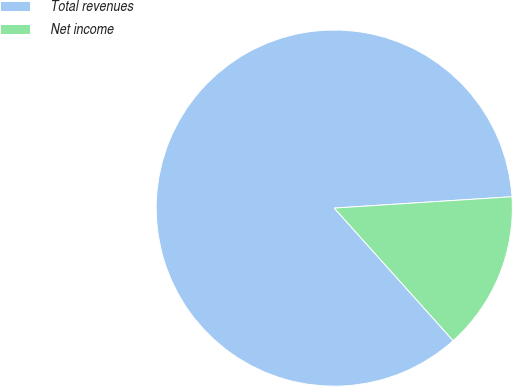<chart> <loc_0><loc_0><loc_500><loc_500><pie_chart><fcel>Total revenues<fcel>Net income<nl><fcel>85.62%<fcel>14.38%<nl></chart> 